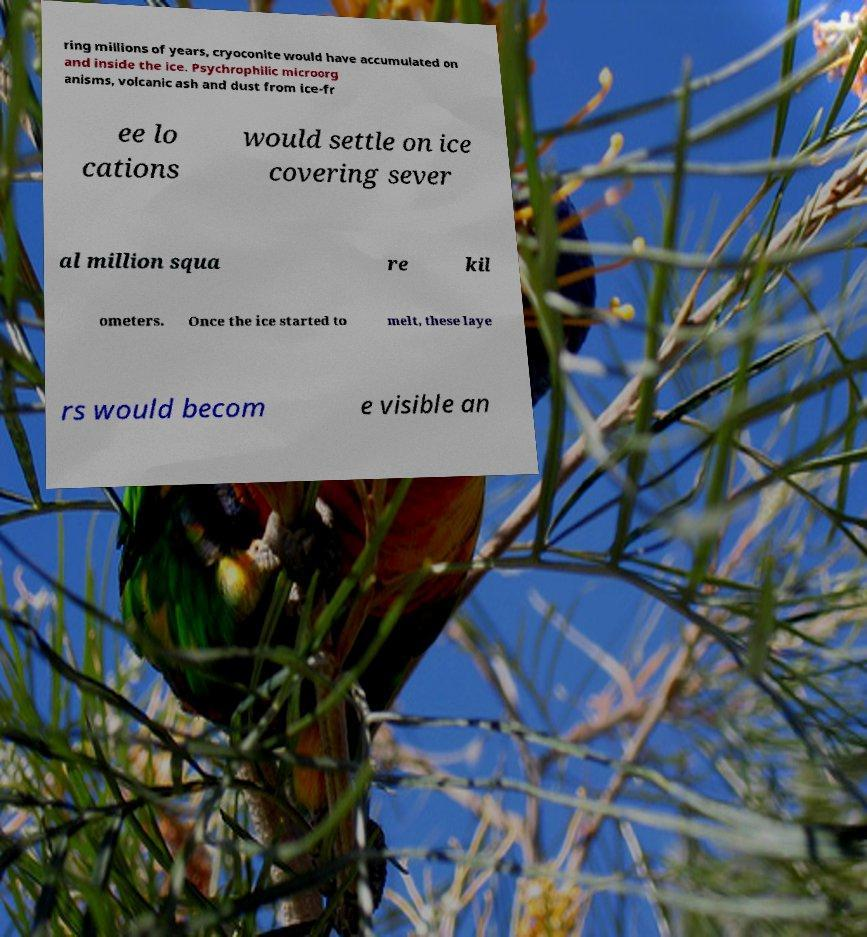Please read and relay the text visible in this image. What does it say? ring millions of years, cryoconite would have accumulated on and inside the ice. Psychrophilic microorg anisms, volcanic ash and dust from ice-fr ee lo cations would settle on ice covering sever al million squa re kil ometers. Once the ice started to melt, these laye rs would becom e visible an 